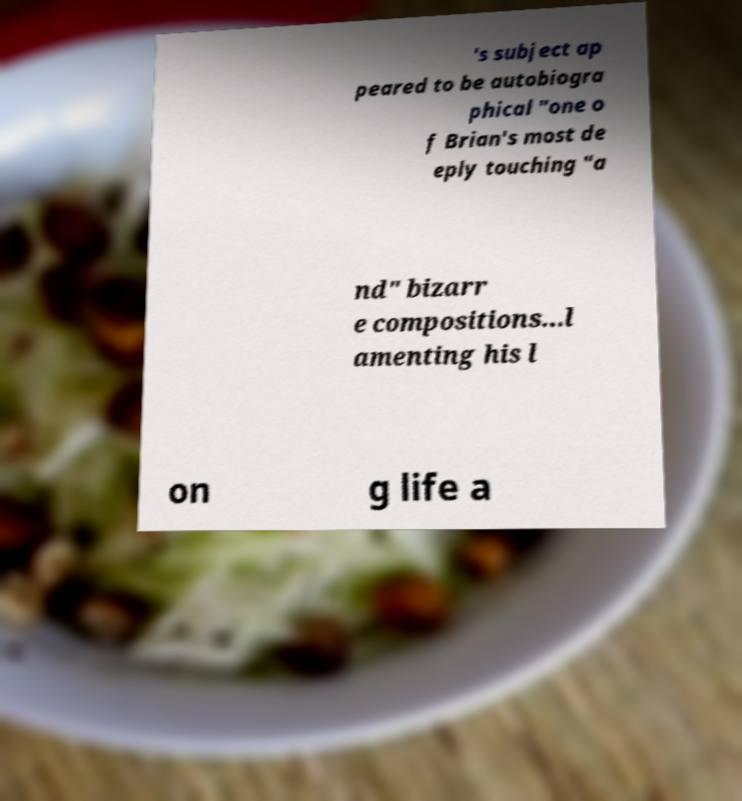Can you read and provide the text displayed in the image?This photo seems to have some interesting text. Can you extract and type it out for me? 's subject ap peared to be autobiogra phical "one o f Brian's most de eply touching "a nd" bizarr e compositions...l amenting his l on g life a 